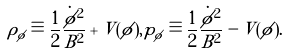Convert formula to latex. <formula><loc_0><loc_0><loc_500><loc_500>\rho _ { \phi } \equiv \frac { 1 } { 2 } \frac { \dot { \phi } ^ { 2 } } { B ^ { 2 } } + V ( \phi ) , p _ { \phi } \equiv \frac { 1 } { 2 } \frac { \dot { \phi } ^ { 2 } } { B ^ { 2 } } - V ( \phi ) .</formula> 